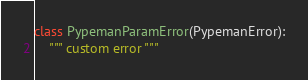<code> <loc_0><loc_0><loc_500><loc_500><_Python_>class PypemanParamError(PypemanError):
    """ custom error """
</code> 